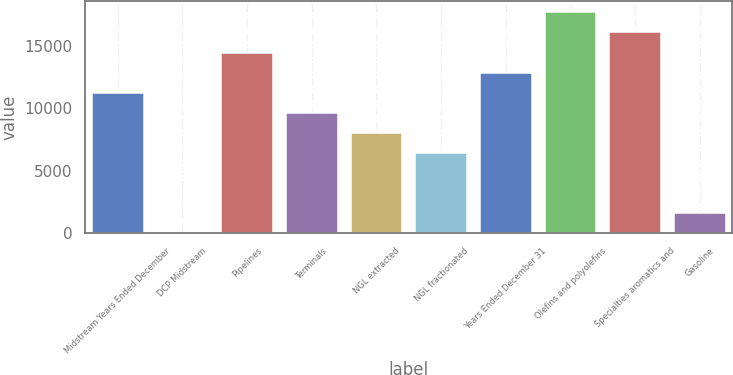<chart> <loc_0><loc_0><loc_500><loc_500><bar_chart><fcel>Midstream Years Ended December<fcel>DCP Midstream<fcel>Pipelines<fcel>Terminals<fcel>NGL extracted<fcel>NGL fractionated<fcel>Years Ended December 31<fcel>Olefins and polyolefins<fcel>Specialties aromatics and<fcel>Gasoline<nl><fcel>11249.9<fcel>0.76<fcel>14463.9<fcel>9642.88<fcel>8035.86<fcel>6428.84<fcel>12856.9<fcel>17678<fcel>16071<fcel>1607.78<nl></chart> 